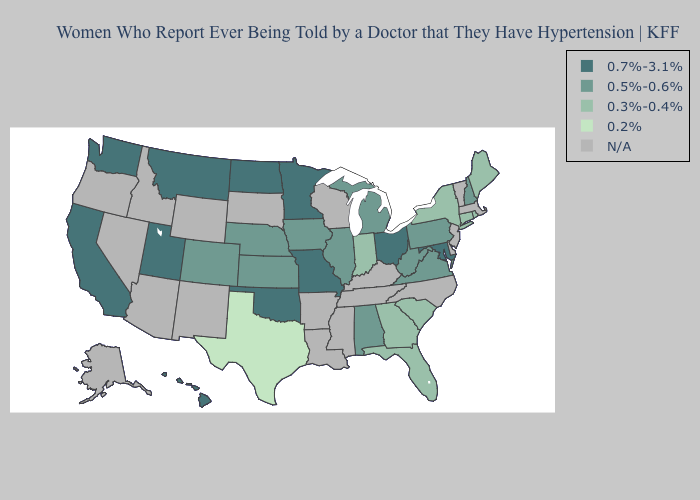Which states have the lowest value in the Northeast?
Short answer required. Connecticut, Maine, New York, Rhode Island. Does Rhode Island have the lowest value in the Northeast?
Concise answer only. Yes. Among the states that border Arizona , which have the lowest value?
Quick response, please. Colorado. Does Texas have the lowest value in the USA?
Be succinct. Yes. Name the states that have a value in the range 0.5%-0.6%?
Short answer required. Alabama, Colorado, Illinois, Iowa, Kansas, Michigan, Nebraska, New Hampshire, Pennsylvania, Virginia, West Virginia. Name the states that have a value in the range 0.7%-3.1%?
Write a very short answer. California, Hawaii, Maryland, Minnesota, Missouri, Montana, North Dakota, Ohio, Oklahoma, Utah, Washington. Name the states that have a value in the range N/A?
Short answer required. Alaska, Arizona, Arkansas, Delaware, Idaho, Kentucky, Louisiana, Massachusetts, Mississippi, Nevada, New Jersey, New Mexico, North Carolina, Oregon, South Dakota, Tennessee, Vermont, Wisconsin, Wyoming. Does the first symbol in the legend represent the smallest category?
Keep it brief. No. Among the states that border North Carolina , which have the lowest value?
Give a very brief answer. Georgia, South Carolina. Which states have the highest value in the USA?
Write a very short answer. California, Hawaii, Maryland, Minnesota, Missouri, Montana, North Dakota, Ohio, Oklahoma, Utah, Washington. Name the states that have a value in the range 0.7%-3.1%?
Write a very short answer. California, Hawaii, Maryland, Minnesota, Missouri, Montana, North Dakota, Ohio, Oklahoma, Utah, Washington. What is the value of Minnesota?
Quick response, please. 0.7%-3.1%. What is the highest value in the USA?
Be succinct. 0.7%-3.1%. Which states have the lowest value in the USA?
Be succinct. Texas. Which states have the lowest value in the South?
Write a very short answer. Texas. 